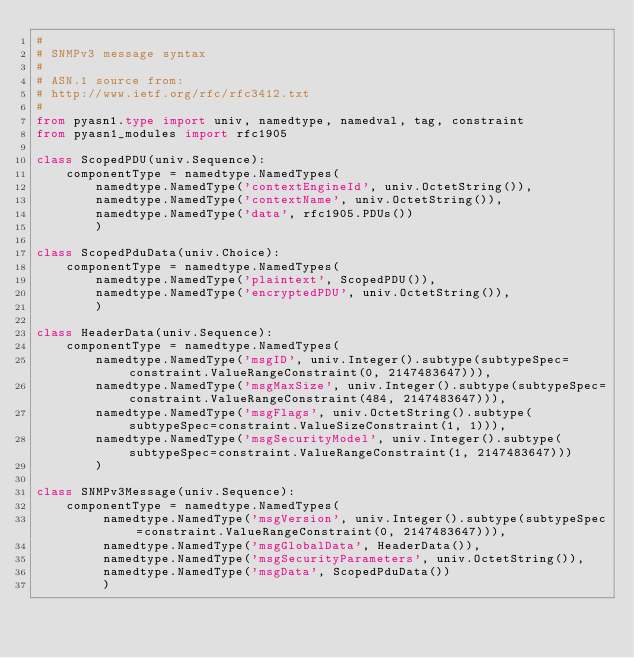Convert code to text. <code><loc_0><loc_0><loc_500><loc_500><_Python_>#
# SNMPv3 message syntax
#
# ASN.1 source from:
# http://www.ietf.org/rfc/rfc3412.txt
#
from pyasn1.type import univ, namedtype, namedval, tag, constraint
from pyasn1_modules import rfc1905

class ScopedPDU(univ.Sequence):
    componentType = namedtype.NamedTypes(
        namedtype.NamedType('contextEngineId', univ.OctetString()),
        namedtype.NamedType('contextName', univ.OctetString()),
        namedtype.NamedType('data', rfc1905.PDUs())
        )
    
class ScopedPduData(univ.Choice):
    componentType = namedtype.NamedTypes(
        namedtype.NamedType('plaintext', ScopedPDU()),
        namedtype.NamedType('encryptedPDU', univ.OctetString()),
        )
    
class HeaderData(univ.Sequence):
    componentType = namedtype.NamedTypes(
        namedtype.NamedType('msgID', univ.Integer().subtype(subtypeSpec=constraint.ValueRangeConstraint(0, 2147483647))),
        namedtype.NamedType('msgMaxSize', univ.Integer().subtype(subtypeSpec=constraint.ValueRangeConstraint(484, 2147483647))),
        namedtype.NamedType('msgFlags', univ.OctetString().subtype(subtypeSpec=constraint.ValueSizeConstraint(1, 1))),
        namedtype.NamedType('msgSecurityModel', univ.Integer().subtype(subtypeSpec=constraint.ValueRangeConstraint(1, 2147483647)))
        )

class SNMPv3Message(univ.Sequence):
    componentType = namedtype.NamedTypes(
         namedtype.NamedType('msgVersion', univ.Integer().subtype(subtypeSpec=constraint.ValueRangeConstraint(0, 2147483647))),
         namedtype.NamedType('msgGlobalData', HeaderData()),
         namedtype.NamedType('msgSecurityParameters', univ.OctetString()),
         namedtype.NamedType('msgData', ScopedPduData())
         )

</code> 